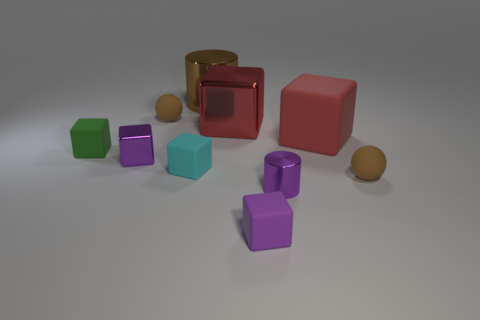Subtract all small purple cubes. How many cubes are left? 4 Subtract all cylinders. How many objects are left? 8 Subtract all cyan cubes. How many cubes are left? 5 Subtract all tiny purple metal objects. Subtract all cyan rubber cubes. How many objects are left? 7 Add 9 small purple shiny cylinders. How many small purple shiny cylinders are left? 10 Add 6 tiny metal objects. How many tiny metal objects exist? 8 Subtract 0 cyan cylinders. How many objects are left? 10 Subtract 1 cylinders. How many cylinders are left? 1 Subtract all yellow balls. Subtract all green cubes. How many balls are left? 2 Subtract all cyan cubes. How many red spheres are left? 0 